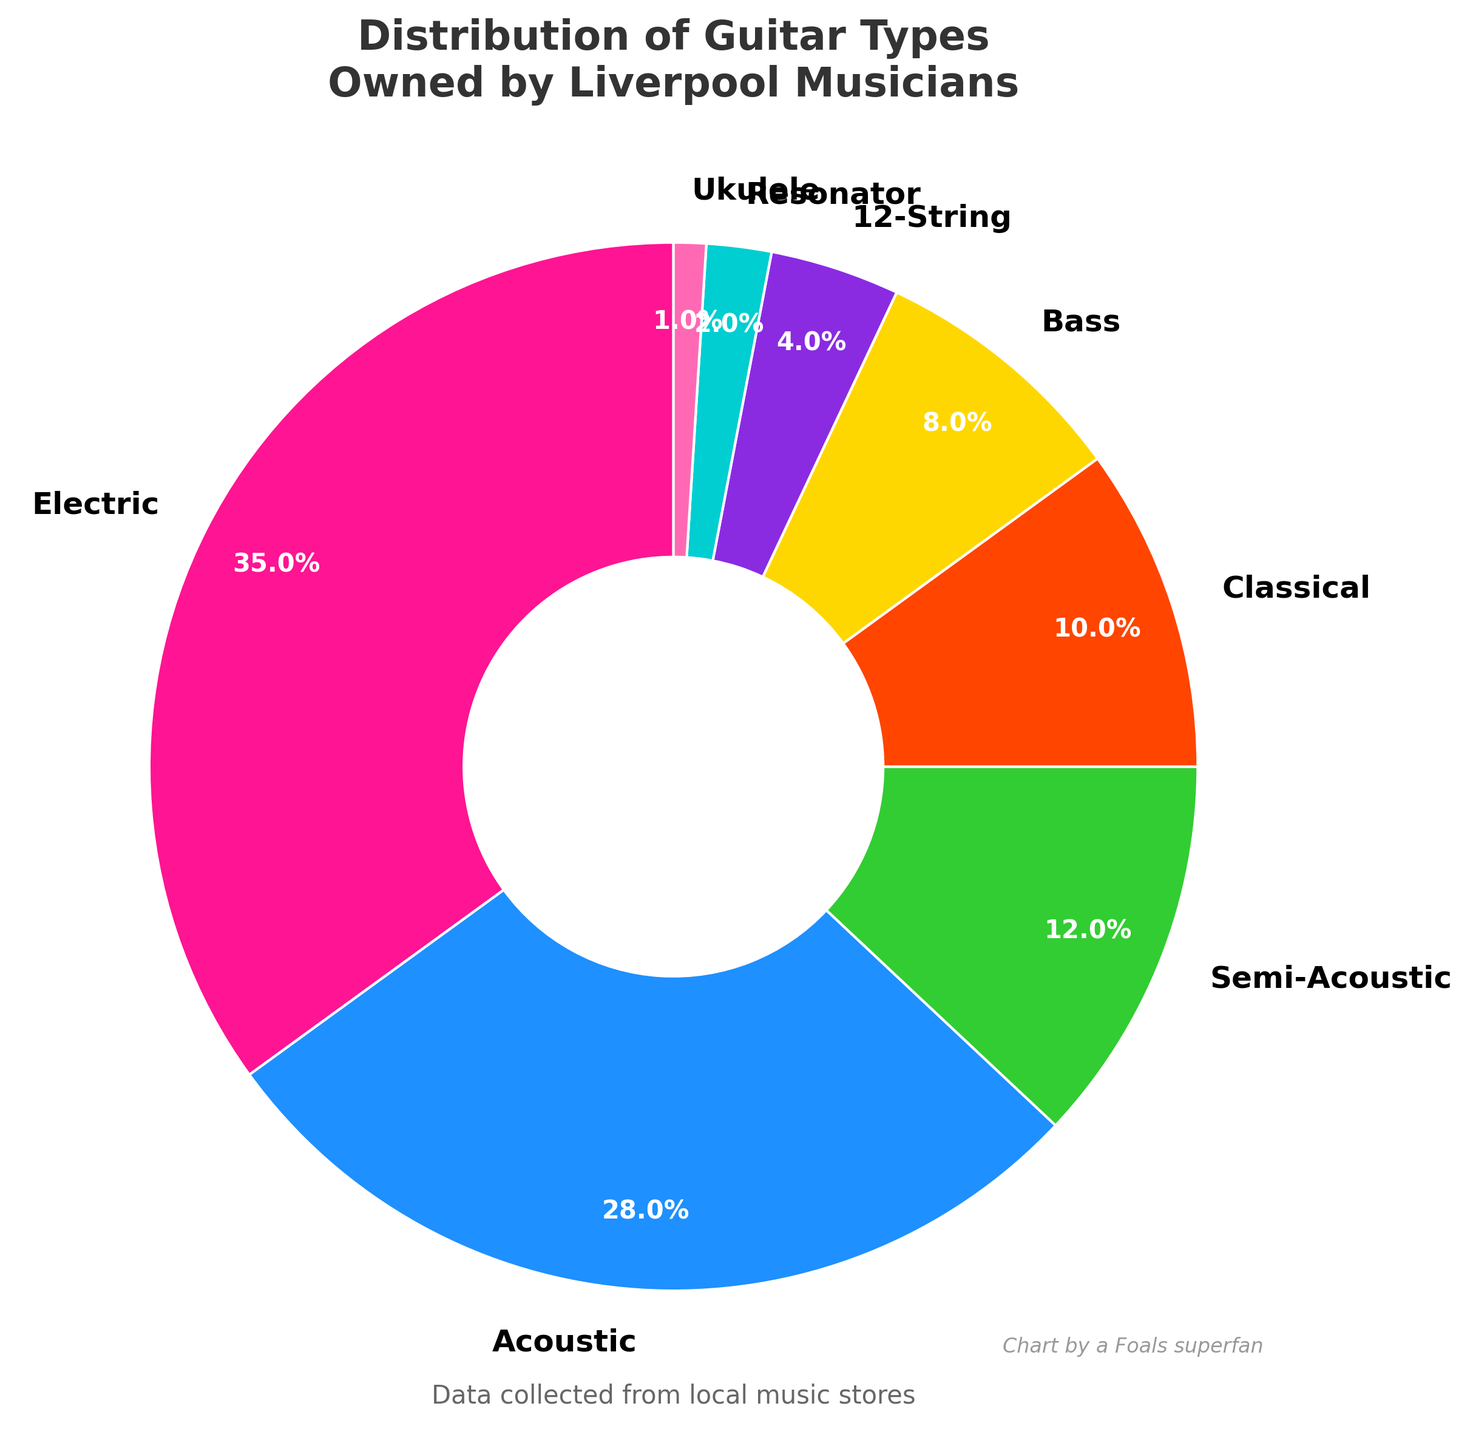Which type of guitar is the most commonly owned by Liverpool musicians? Look at the pie chart and find the guitar type with the largest percentage. Here, the Electric guitar has the largest slice, representing 35%.
Answer: Electric How much more common are Electric guitars compared to Classical guitars? The Electric guitars represent 35%, while the Classical guitars represent 10%. Subtract the percentage of Classical guitars from Electric guitars: 35% - 10% = 25%.
Answer: 25% What percentage of Liverpool musicians own either Semi-Acoustic or Bass guitars? Add the percentages for Semi-Acoustic and Bass guitars: 12% (Semi-Acoustic) + 8% (Bass) = 20%.
Answer: 20% Which guitar types together make up exactly half of the total percentage? We need to find a combination of guitar types whose percentages sum up to 50%. Electric (35%) + Acoustic (28%) > 50%, and therefore, they do not qualify. However, if you try Acoustic (28%) + Semi-Acoustic (12%) + Classical (10%), it equals 50%.
Answer: Acoustic, Semi-Acoustic, Classical Are there more Liverpool musicians who own Resonator guitars or Ukuleles? Compare the percentages of those who own Resonator guitars (2%) to those who own Ukuleles (1%). Since 2% > 1%, more musicians own Resonator guitars than Ukuleles.
Answer: Resonator guitars How much percentage more common are Acoustic guitars compared to Bass guitars? The percentage for Acoustic guitars is 28%, and for Bass guitars, it is 8%. Subtract the Bass guitar percentage from the Acoustic guitar percentage: 28% - 8% = 20%.
Answer: 20% If we combine the percentages of 12-String guitars and Ukuleles, do they match or exceed the percentage of Classical guitars? Add the percentages of 12-String guitars (4%) and Ukuleles (1%), which equals 5%. Then compare this to the percentage of Classical guitars (10%). Since 5% < 10%, the combined percentage is less.
Answer: No Among the guitar types shown, which one is the least owned by Liverpool musicians? Identify the guitar type with the smallest percentage on the pie chart. Ukulele has the smallest slice, representing 1%.
Answer: Ukulele If you add the percentages of Semi-Acoustic and 12-String guitars, is the total higher or lower than Acoustic guitars? Sum the percentages of Semi-Acoustic (12%) and 12-String (4%) guitars: 12% + 4% = 16%. Compare this with the percentage of Acoustic guitars (28%). Since 16% < 28%, it is lower.
Answer: Lower 